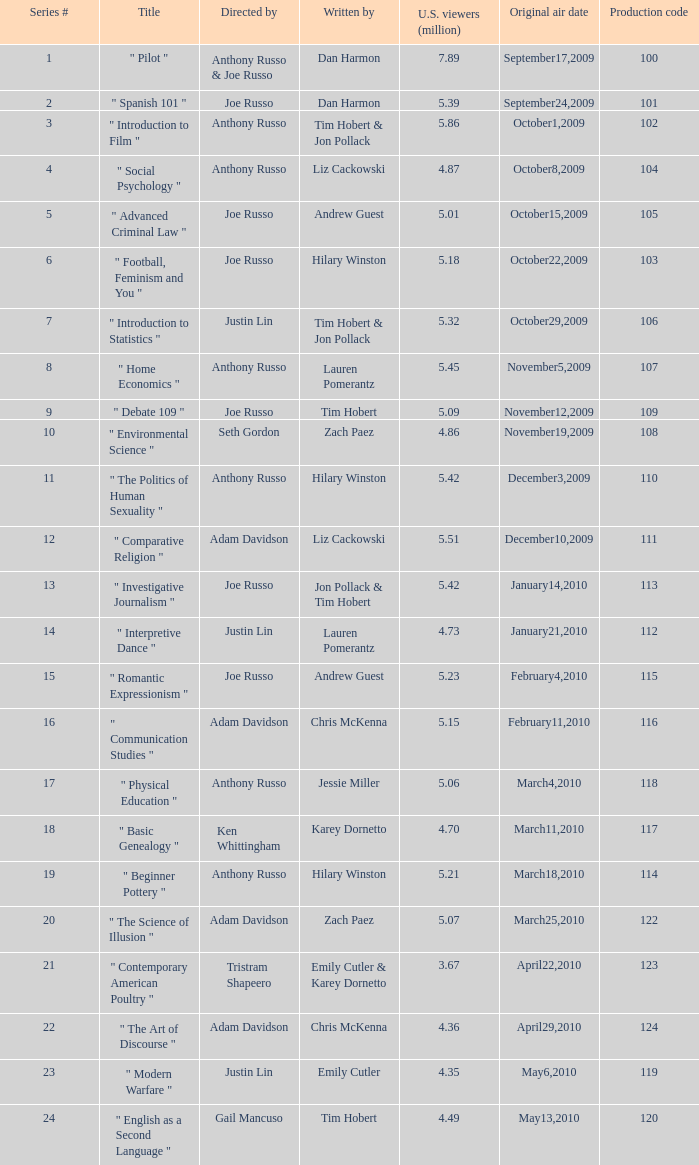What is the title of the series # 8? " Home Economics ". 